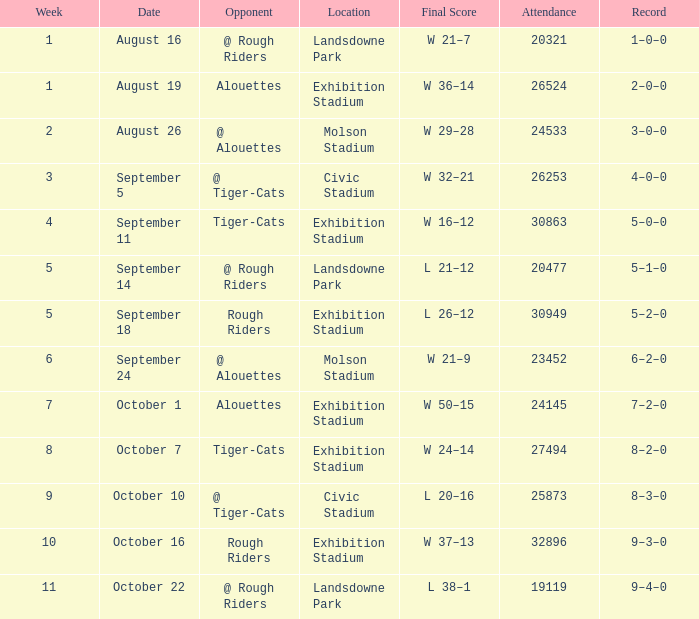On september 5th, how many attendance values are there? 1.0. Write the full table. {'header': ['Week', 'Date', 'Opponent', 'Location', 'Final Score', 'Attendance', 'Record'], 'rows': [['1', 'August 16', '@ Rough Riders', 'Landsdowne Park', 'W 21–7', '20321', '1–0–0'], ['1', 'August 19', 'Alouettes', 'Exhibition Stadium', 'W 36–14', '26524', '2–0–0'], ['2', 'August 26', '@ Alouettes', 'Molson Stadium', 'W 29–28', '24533', '3–0–0'], ['3', 'September 5', '@ Tiger-Cats', 'Civic Stadium', 'W 32–21', '26253', '4–0–0'], ['4', 'September 11', 'Tiger-Cats', 'Exhibition Stadium', 'W 16–12', '30863', '5–0–0'], ['5', 'September 14', '@ Rough Riders', 'Landsdowne Park', 'L 21–12', '20477', '5–1–0'], ['5', 'September 18', 'Rough Riders', 'Exhibition Stadium', 'L 26–12', '30949', '5–2–0'], ['6', 'September 24', '@ Alouettes', 'Molson Stadium', 'W 21–9', '23452', '6–2–0'], ['7', 'October 1', 'Alouettes', 'Exhibition Stadium', 'W 50–15', '24145', '7–2–0'], ['8', 'October 7', 'Tiger-Cats', 'Exhibition Stadium', 'W 24–14', '27494', '8–2–0'], ['9', 'October 10', '@ Tiger-Cats', 'Civic Stadium', 'L 20–16', '25873', '8–3–0'], ['10', 'October 16', 'Rough Riders', 'Exhibition Stadium', 'W 37–13', '32896', '9–3–0'], ['11', 'October 22', '@ Rough Riders', 'Landsdowne Park', 'L 38–1', '19119', '9–4–0']]} 